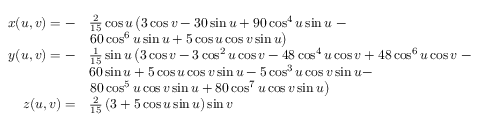<formula> <loc_0><loc_0><loc_500><loc_500>{ \begin{array} { r l } { x ( u , v ) = - } & { { \frac { 2 } { 1 5 } } \cos u \left ( 3 \cos { v } - 3 0 \sin { u } + 9 0 \cos ^ { 4 } { u } \sin { u } - } \\ & { 6 0 \cos ^ { 6 } { u } \sin { u } + 5 \cos { u } \cos { v } \sin { u } \right ) } \\ { y ( u , v ) = - } & { { \frac { 1 } { 1 5 } } \sin u \left ( 3 \cos { v } - 3 \cos ^ { 2 } { u } \cos { v } - 4 8 \cos ^ { 4 } { u } \cos { v } + 4 8 \cos ^ { 6 } { u } \cos { v } - } \\ & { 6 0 \sin { u } + 5 \cos { u } \cos { v } \sin { u } - 5 \cos ^ { 3 } { u } \cos { v } \sin { u } - } \\ & { 8 0 \cos ^ { 5 } { u } \cos { v } \sin { u } + 8 0 \cos ^ { 7 } { u } \cos { v } \sin { u } \right ) } \\ { z ( u , v ) = } & { { \frac { 2 } { 1 5 } } \left ( 3 + 5 \cos { u } \sin { u } \right ) \sin { v } } \end{array} }</formula> 